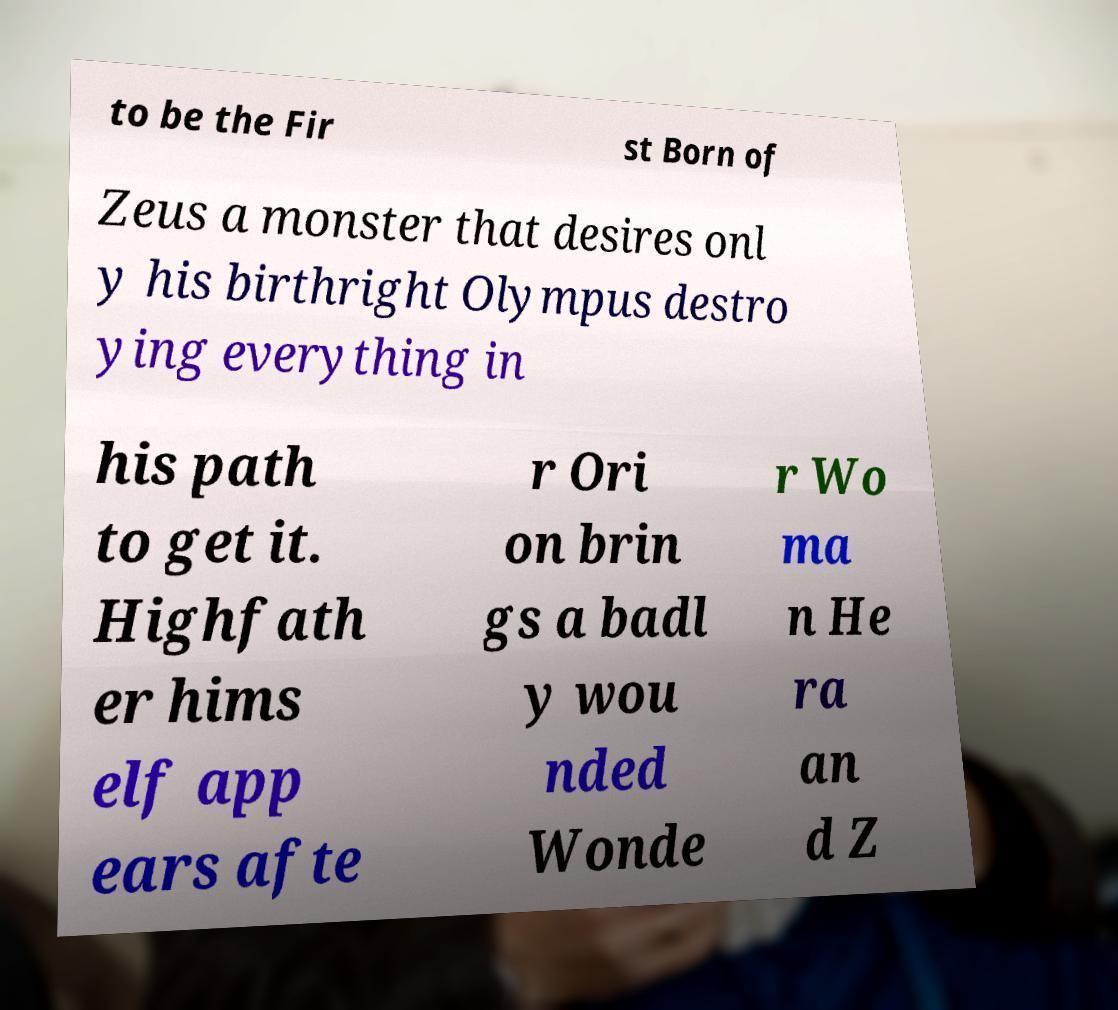Can you accurately transcribe the text from the provided image for me? to be the Fir st Born of Zeus a monster that desires onl y his birthright Olympus destro ying everything in his path to get it. Highfath er hims elf app ears afte r Ori on brin gs a badl y wou nded Wonde r Wo ma n He ra an d Z 